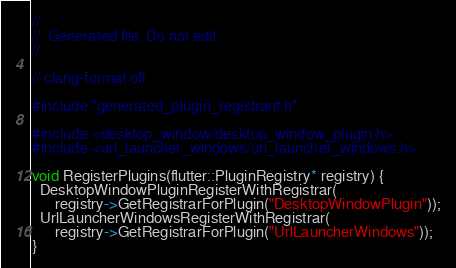Convert code to text. <code><loc_0><loc_0><loc_500><loc_500><_C++_>//
//  Generated file. Do not edit.
//

// clang-format off

#include "generated_plugin_registrant.h"

#include <desktop_window/desktop_window_plugin.h>
#include <url_launcher_windows/url_launcher_windows.h>

void RegisterPlugins(flutter::PluginRegistry* registry) {
  DesktopWindowPluginRegisterWithRegistrar(
      registry->GetRegistrarForPlugin("DesktopWindowPlugin"));
  UrlLauncherWindowsRegisterWithRegistrar(
      registry->GetRegistrarForPlugin("UrlLauncherWindows"));
}
</code> 